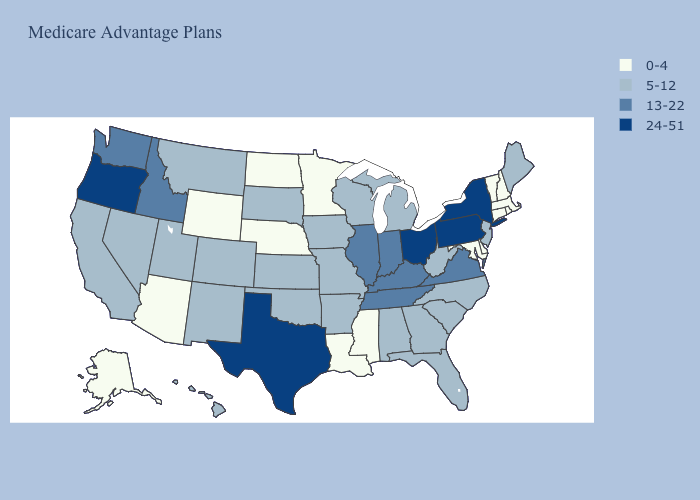What is the lowest value in the USA?
Write a very short answer. 0-4. Name the states that have a value in the range 0-4?
Keep it brief. Alaska, Arizona, Connecticut, Delaware, Louisiana, Massachusetts, Maryland, Minnesota, Mississippi, North Dakota, Nebraska, New Hampshire, Rhode Island, Vermont, Wyoming. Name the states that have a value in the range 13-22?
Be succinct. Idaho, Illinois, Indiana, Kentucky, Tennessee, Virginia, Washington. What is the highest value in the USA?
Concise answer only. 24-51. Is the legend a continuous bar?
Concise answer only. No. Among the states that border South Dakota , which have the lowest value?
Concise answer only. Minnesota, North Dakota, Nebraska, Wyoming. What is the value of Iowa?
Short answer required. 5-12. Which states hav the highest value in the MidWest?
Short answer required. Ohio. Name the states that have a value in the range 24-51?
Keep it brief. New York, Ohio, Oregon, Pennsylvania, Texas. Does the map have missing data?
Answer briefly. No. Does the map have missing data?
Be succinct. No. Is the legend a continuous bar?
Quick response, please. No. Does Texas have a higher value than Illinois?
Quick response, please. Yes. Does New Jersey have the same value as Nebraska?
Concise answer only. No. 